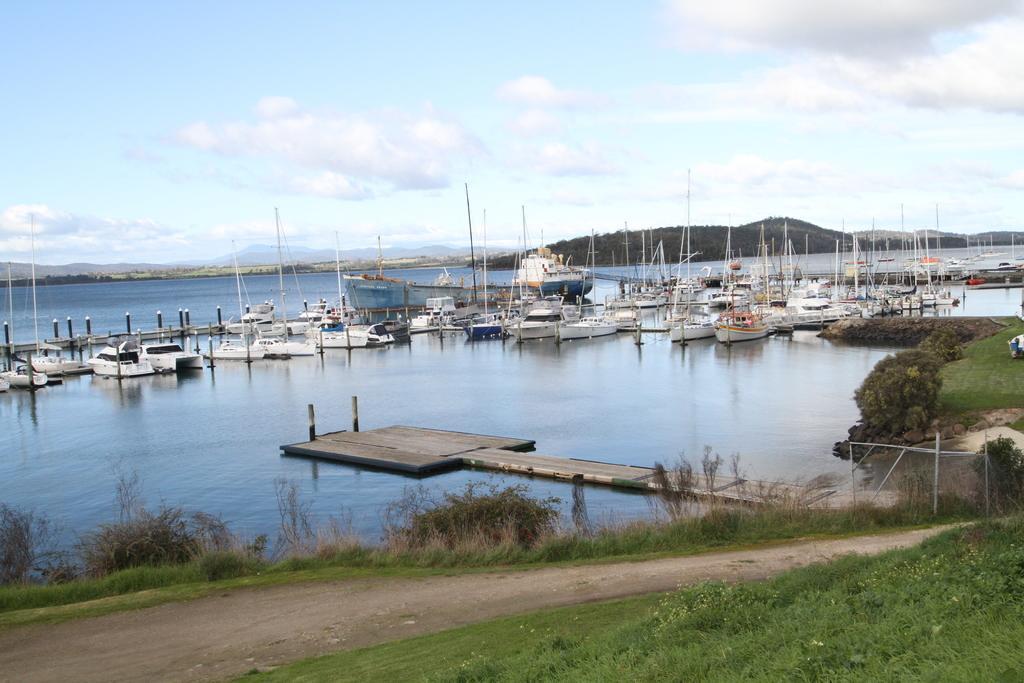Can you describe this image briefly? In this image there are so many boats in the water. In the middle there is a bridge. At the bottom there is a path, beside the path there are small plants. At the top there is the sky. In the background there are hills. 